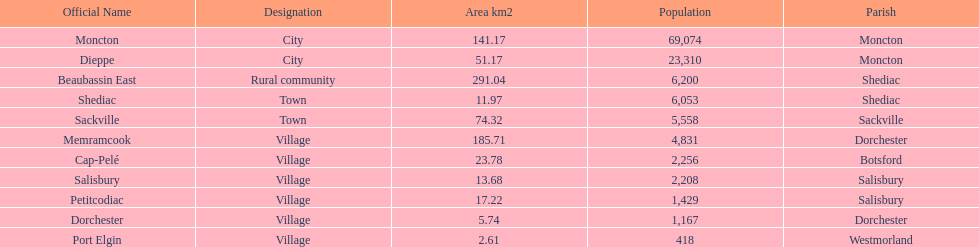In which municipality do the highest number of residents live? Moncton. 